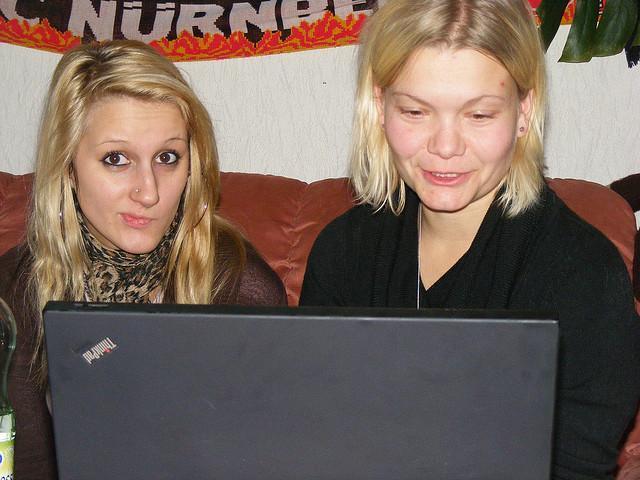How many ladies are there in the picture?
Give a very brief answer. 2. How many people can be seen?
Give a very brief answer. 2. 